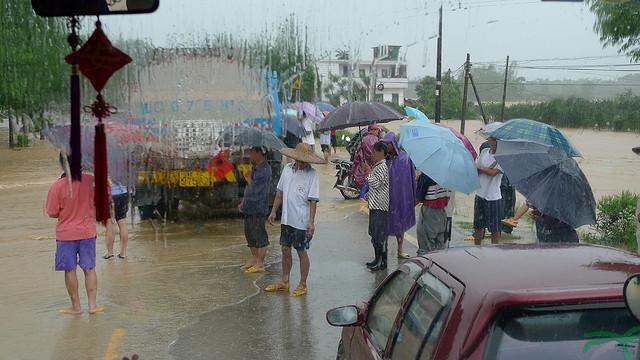What is on the woman in oranges head?
Keep it brief. Umbrella. Why is the person using an umbrella?
Concise answer only. Raining. Are they wearing helmets?
Give a very brief answer. No. What is the event?
Be succinct. Flood. Does the umbrella have two colors on it?
Be succinct. Yes. Is it raining outside?
Quick response, please. Yes. How is the weather?
Quick response, please. Rainy. What are many people holding?
Give a very brief answer. Umbrellas. What are they carrying?
Answer briefly. Umbrellas. What is the job of the person in red?
Write a very short answer. Spectator. Where is the photographer sitting?
Short answer required. In bus. How many vehicles are visible?
Be succinct. 1. How many red umbrellas?
Answer briefly. 1. 